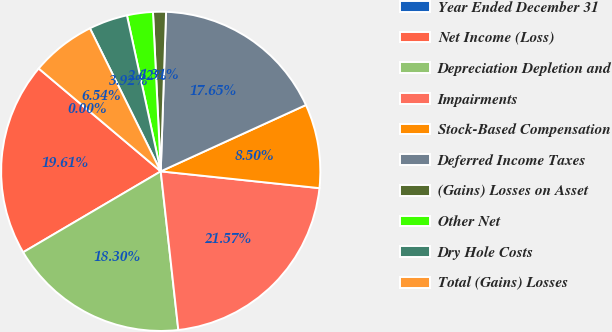<chart> <loc_0><loc_0><loc_500><loc_500><pie_chart><fcel>Year Ended December 31<fcel>Net Income (Loss)<fcel>Depreciation Depletion and<fcel>Impairments<fcel>Stock-Based Compensation<fcel>Deferred Income Taxes<fcel>(Gains) Losses on Asset<fcel>Other Net<fcel>Dry Hole Costs<fcel>Total (Gains) Losses<nl><fcel>0.0%<fcel>19.61%<fcel>18.3%<fcel>21.57%<fcel>8.5%<fcel>17.65%<fcel>1.31%<fcel>2.62%<fcel>3.92%<fcel>6.54%<nl></chart> 